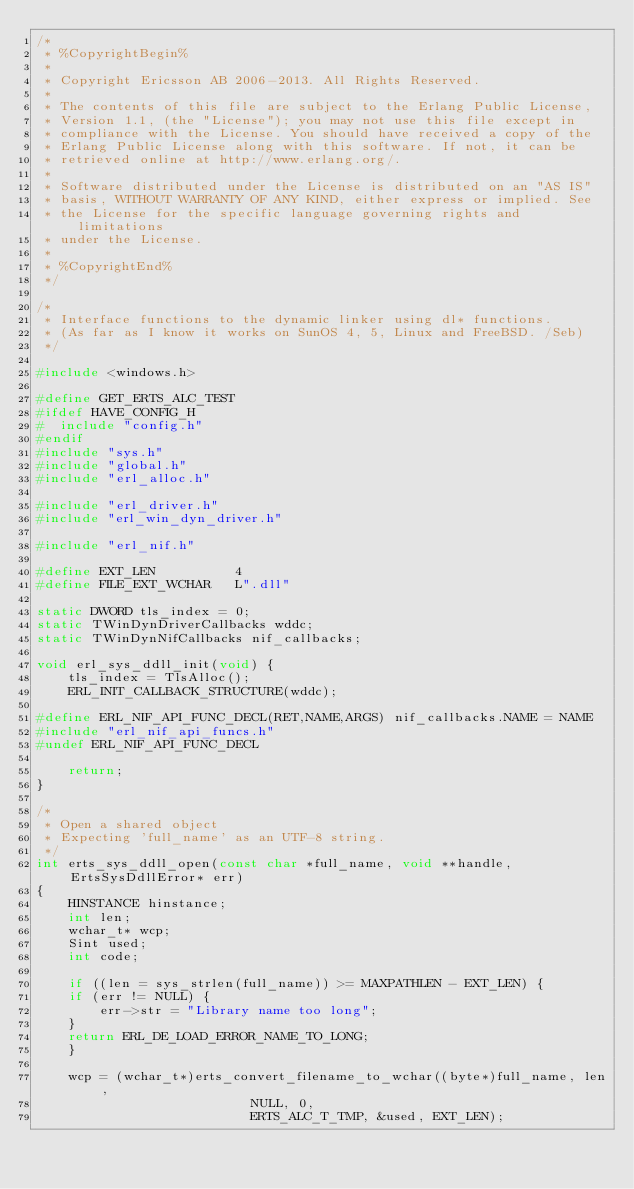<code> <loc_0><loc_0><loc_500><loc_500><_C_>/*
 * %CopyrightBegin%
 * 
 * Copyright Ericsson AB 2006-2013. All Rights Reserved.
 * 
 * The contents of this file are subject to the Erlang Public License,
 * Version 1.1, (the "License"); you may not use this file except in
 * compliance with the License. You should have received a copy of the
 * Erlang Public License along with this software. If not, it can be
 * retrieved online at http://www.erlang.org/.
 * 
 * Software distributed under the License is distributed on an "AS IS"
 * basis, WITHOUT WARRANTY OF ANY KIND, either express or implied. See
 * the License for the specific language governing rights and limitations
 * under the License.
 * 
 * %CopyrightEnd%
 */

/* 
 * Interface functions to the dynamic linker using dl* functions.
 * (As far as I know it works on SunOS 4, 5, Linux and FreeBSD. /Seb) 
 */

#include <windows.h>

#define GET_ERTS_ALC_TEST
#ifdef HAVE_CONFIG_H
#  include "config.h"
#endif
#include "sys.h"
#include "global.h"
#include "erl_alloc.h"

#include "erl_driver.h"
#include "erl_win_dyn_driver.h"

#include "erl_nif.h"

#define EXT_LEN          4
#define FILE_EXT_WCHAR   L".dll"

static DWORD tls_index = 0;
static TWinDynDriverCallbacks wddc;
static TWinDynNifCallbacks nif_callbacks;

void erl_sys_ddll_init(void) {
    tls_index = TlsAlloc();
    ERL_INIT_CALLBACK_STRUCTURE(wddc);

#define ERL_NIF_API_FUNC_DECL(RET,NAME,ARGS) nif_callbacks.NAME = NAME
#include "erl_nif_api_funcs.h"
#undef ERL_NIF_API_FUNC_DECL
   
    return;
}

/* 
 * Open a shared object
 * Expecting 'full_name' as an UTF-8 string.
 */
int erts_sys_ddll_open(const char *full_name, void **handle, ErtsSysDdllError* err)
{
    HINSTANCE hinstance;
    int len;
    wchar_t* wcp;
    Sint used;
    int code;
    
    if ((len = sys_strlen(full_name)) >= MAXPATHLEN - EXT_LEN) {
	if (err != NULL) {
	    err->str = "Library name too long";
	}
	return ERL_DE_LOAD_ERROR_NAME_TO_LONG;
    }

    wcp = (wchar_t*)erts_convert_filename_to_wchar((byte*)full_name, len,
						   NULL, 0,
						   ERTS_ALC_T_TMP, &used, EXT_LEN);</code> 